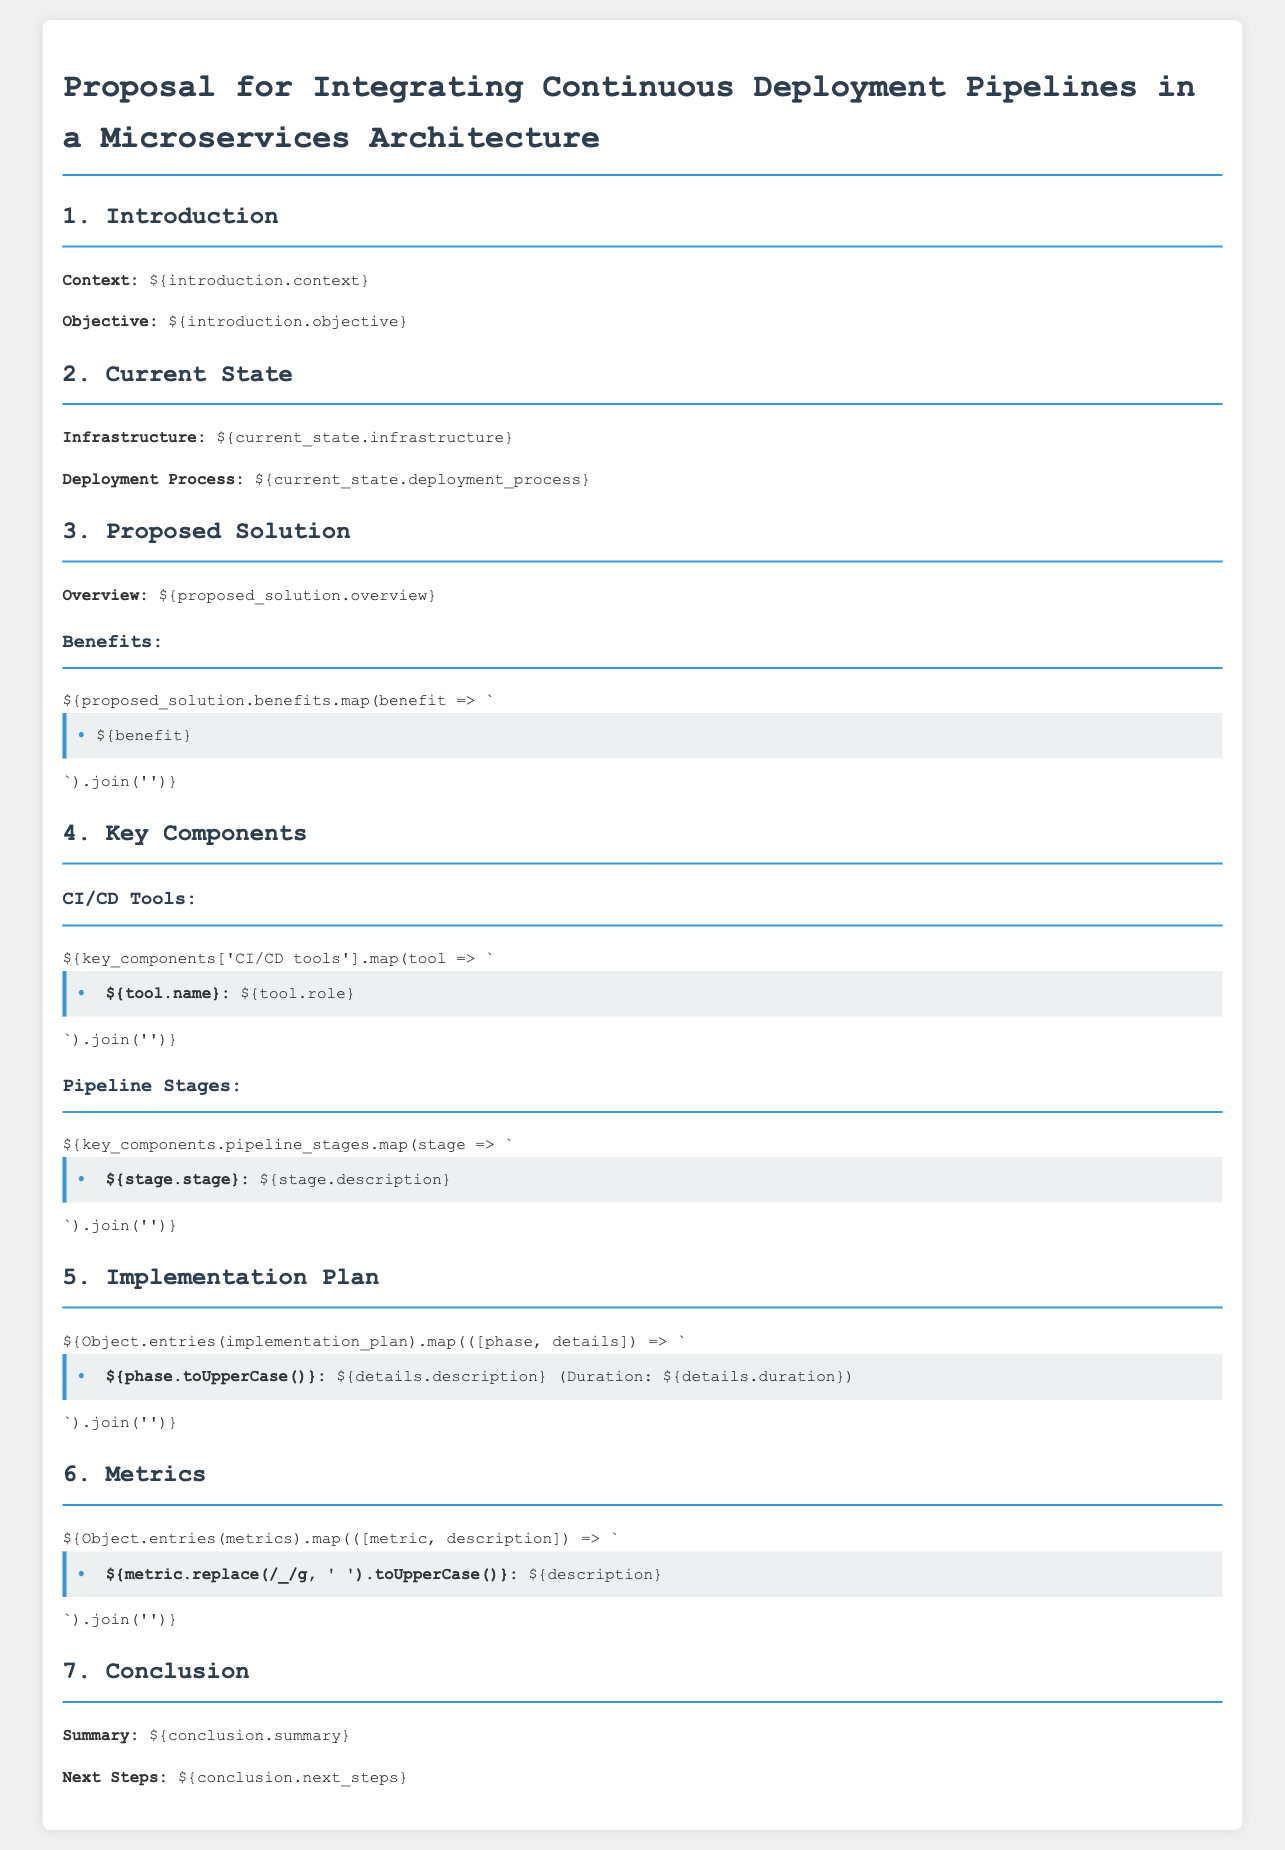What is the title of the proposal? The title of the proposal is mentioned at the top of the document.
Answer: Proposal for Integrating Continuous Deployment Pipelines in a Microservices Architecture What is the objective of the proposal? The objective is outlined in the introduction section of the document.
Answer: To integrate continuous deployment pipelines What is the main infrastructure described? The infrastructure is specified in the current state section of the document.
Answer: Microservices architecture How many pipeline stages are listed? The number of pipeline stages can be inferred from the "Key Components" section showing different stages.
Answer: Multiple stages What does the 'Build' stage entail? The description for the 'Build' stage is provided within the pipeline stages section.
Answer: Compiling source code What is the duration of the 'Validation' phase? The duration for each phase is listed in the implementation plan.
Answer: Two weeks What is a key metric for success? Success metrics are outlined in the metrics section of the document.
Answer: Deployment frequency What is the first next step mentioned? The next steps are discussed in the conclusion section of the document.
Answer: Gain stakeholder approval 